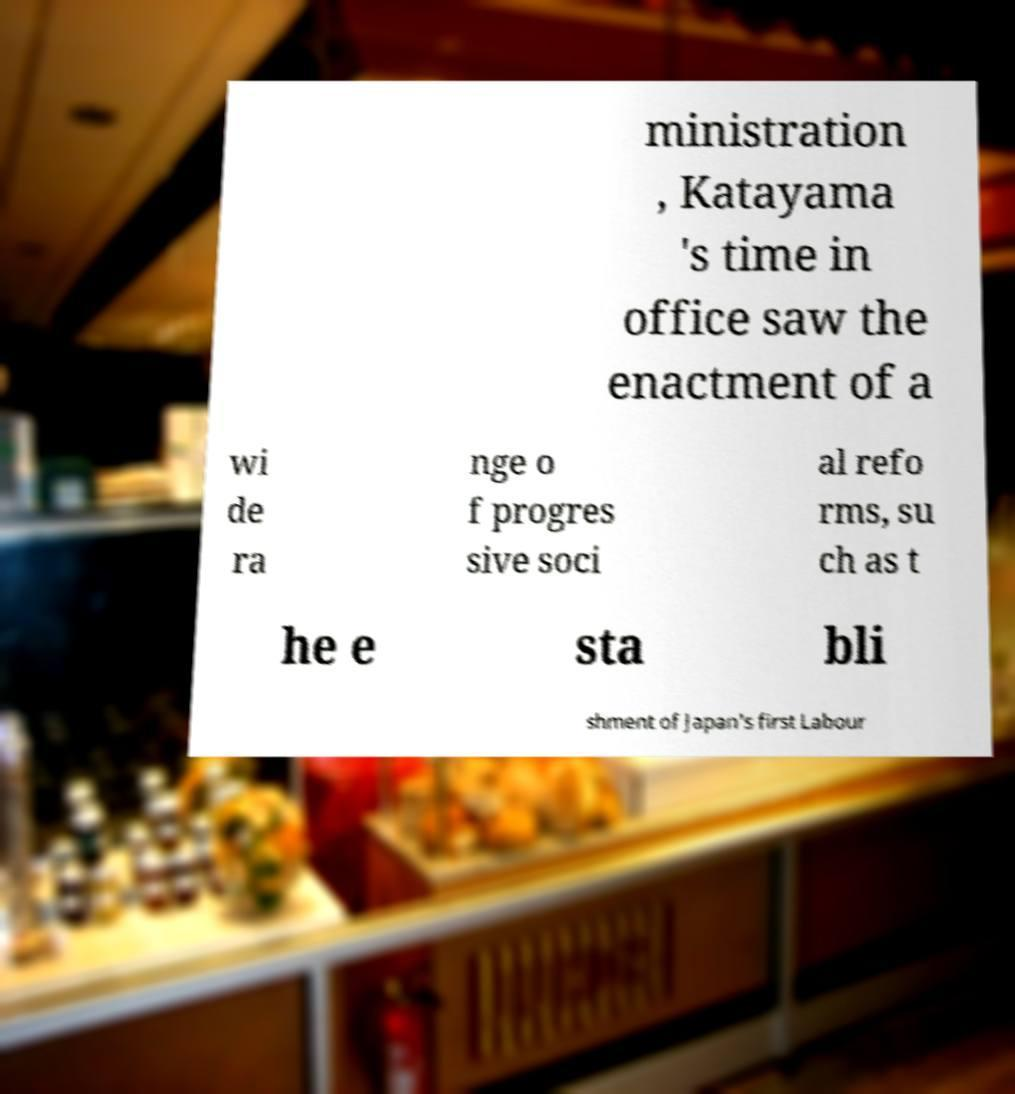What messages or text are displayed in this image? I need them in a readable, typed format. ministration , Katayama 's time in office saw the enactment of a wi de ra nge o f progres sive soci al refo rms, su ch as t he e sta bli shment of Japan's first Labour 